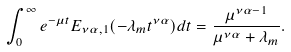<formula> <loc_0><loc_0><loc_500><loc_500>\int _ { 0 } ^ { \infty } e ^ { - \mu t } E _ { \nu \alpha , 1 } ( - \lambda _ { m } t ^ { \nu \alpha } ) d t = \frac { \mu ^ { \nu \alpha - 1 } } { \mu ^ { \nu \alpha } + \lambda _ { m } } .</formula> 